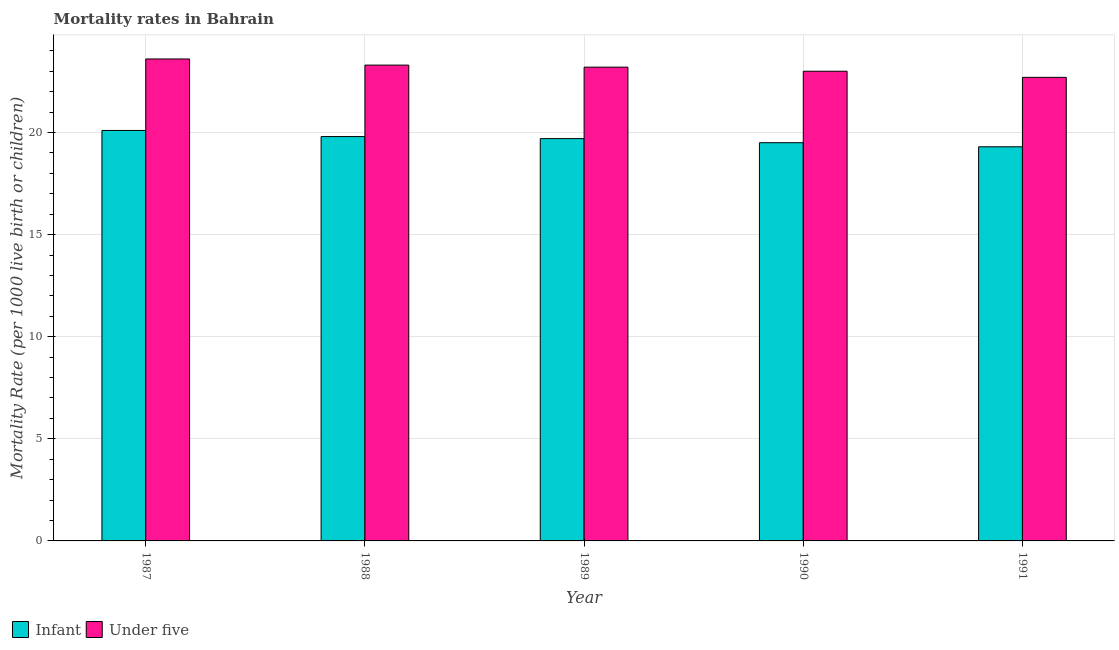Are the number of bars per tick equal to the number of legend labels?
Ensure brevity in your answer.  Yes. Are the number of bars on each tick of the X-axis equal?
Your response must be concise. Yes. How many bars are there on the 2nd tick from the right?
Ensure brevity in your answer.  2. Across all years, what is the maximum under-5 mortality rate?
Provide a short and direct response. 23.6. Across all years, what is the minimum infant mortality rate?
Your response must be concise. 19.3. In which year was the under-5 mortality rate maximum?
Provide a succinct answer. 1987. What is the total infant mortality rate in the graph?
Your answer should be very brief. 98.4. What is the difference between the infant mortality rate in 1987 and that in 1991?
Your answer should be compact. 0.8. What is the average infant mortality rate per year?
Offer a very short reply. 19.68. What is the ratio of the under-5 mortality rate in 1987 to that in 1989?
Offer a terse response. 1.02. Is the under-5 mortality rate in 1988 less than that in 1989?
Your answer should be compact. No. What is the difference between the highest and the second highest infant mortality rate?
Ensure brevity in your answer.  0.3. What is the difference between the highest and the lowest under-5 mortality rate?
Provide a short and direct response. 0.9. What does the 1st bar from the left in 1987 represents?
Offer a very short reply. Infant. What does the 1st bar from the right in 1987 represents?
Offer a very short reply. Under five. How many bars are there?
Offer a very short reply. 10. Are the values on the major ticks of Y-axis written in scientific E-notation?
Make the answer very short. No. Does the graph contain grids?
Your response must be concise. Yes. How are the legend labels stacked?
Provide a succinct answer. Horizontal. What is the title of the graph?
Ensure brevity in your answer.  Mortality rates in Bahrain. Does "Travel services" appear as one of the legend labels in the graph?
Ensure brevity in your answer.  No. What is the label or title of the Y-axis?
Make the answer very short. Mortality Rate (per 1000 live birth or children). What is the Mortality Rate (per 1000 live birth or children) of Infant in 1987?
Provide a succinct answer. 20.1. What is the Mortality Rate (per 1000 live birth or children) in Under five in 1987?
Keep it short and to the point. 23.6. What is the Mortality Rate (per 1000 live birth or children) of Infant in 1988?
Keep it short and to the point. 19.8. What is the Mortality Rate (per 1000 live birth or children) in Under five in 1988?
Provide a short and direct response. 23.3. What is the Mortality Rate (per 1000 live birth or children) in Under five in 1989?
Offer a terse response. 23.2. What is the Mortality Rate (per 1000 live birth or children) in Infant in 1991?
Make the answer very short. 19.3. What is the Mortality Rate (per 1000 live birth or children) in Under five in 1991?
Keep it short and to the point. 22.7. Across all years, what is the maximum Mortality Rate (per 1000 live birth or children) in Infant?
Offer a terse response. 20.1. Across all years, what is the maximum Mortality Rate (per 1000 live birth or children) of Under five?
Offer a very short reply. 23.6. Across all years, what is the minimum Mortality Rate (per 1000 live birth or children) in Infant?
Keep it short and to the point. 19.3. Across all years, what is the minimum Mortality Rate (per 1000 live birth or children) of Under five?
Your response must be concise. 22.7. What is the total Mortality Rate (per 1000 live birth or children) in Infant in the graph?
Keep it short and to the point. 98.4. What is the total Mortality Rate (per 1000 live birth or children) of Under five in the graph?
Make the answer very short. 115.8. What is the difference between the Mortality Rate (per 1000 live birth or children) of Infant in 1987 and that in 1988?
Make the answer very short. 0.3. What is the difference between the Mortality Rate (per 1000 live birth or children) in Infant in 1987 and that in 1989?
Keep it short and to the point. 0.4. What is the difference between the Mortality Rate (per 1000 live birth or children) of Under five in 1987 and that in 1989?
Your answer should be very brief. 0.4. What is the difference between the Mortality Rate (per 1000 live birth or children) of Infant in 1987 and that in 1990?
Keep it short and to the point. 0.6. What is the difference between the Mortality Rate (per 1000 live birth or children) of Under five in 1987 and that in 1990?
Provide a short and direct response. 0.6. What is the difference between the Mortality Rate (per 1000 live birth or children) in Under five in 1988 and that in 1989?
Your answer should be very brief. 0.1. What is the difference between the Mortality Rate (per 1000 live birth or children) in Infant in 1988 and that in 1990?
Provide a succinct answer. 0.3. What is the difference between the Mortality Rate (per 1000 live birth or children) of Under five in 1988 and that in 1991?
Give a very brief answer. 0.6. What is the difference between the Mortality Rate (per 1000 live birth or children) of Infant in 1989 and that in 1990?
Your response must be concise. 0.2. What is the difference between the Mortality Rate (per 1000 live birth or children) in Under five in 1989 and that in 1990?
Offer a terse response. 0.2. What is the difference between the Mortality Rate (per 1000 live birth or children) of Infant in 1989 and that in 1991?
Your response must be concise. 0.4. What is the difference between the Mortality Rate (per 1000 live birth or children) of Under five in 1989 and that in 1991?
Offer a terse response. 0.5. What is the difference between the Mortality Rate (per 1000 live birth or children) in Infant in 1990 and that in 1991?
Provide a succinct answer. 0.2. What is the difference between the Mortality Rate (per 1000 live birth or children) in Infant in 1987 and the Mortality Rate (per 1000 live birth or children) in Under five in 1988?
Give a very brief answer. -3.2. What is the difference between the Mortality Rate (per 1000 live birth or children) in Infant in 1987 and the Mortality Rate (per 1000 live birth or children) in Under five in 1989?
Offer a very short reply. -3.1. What is the difference between the Mortality Rate (per 1000 live birth or children) of Infant in 1989 and the Mortality Rate (per 1000 live birth or children) of Under five in 1990?
Your answer should be very brief. -3.3. What is the difference between the Mortality Rate (per 1000 live birth or children) in Infant in 1990 and the Mortality Rate (per 1000 live birth or children) in Under five in 1991?
Your answer should be very brief. -3.2. What is the average Mortality Rate (per 1000 live birth or children) in Infant per year?
Your response must be concise. 19.68. What is the average Mortality Rate (per 1000 live birth or children) in Under five per year?
Your response must be concise. 23.16. In the year 1987, what is the difference between the Mortality Rate (per 1000 live birth or children) of Infant and Mortality Rate (per 1000 live birth or children) of Under five?
Provide a short and direct response. -3.5. In the year 1991, what is the difference between the Mortality Rate (per 1000 live birth or children) of Infant and Mortality Rate (per 1000 live birth or children) of Under five?
Your answer should be compact. -3.4. What is the ratio of the Mortality Rate (per 1000 live birth or children) in Infant in 1987 to that in 1988?
Make the answer very short. 1.02. What is the ratio of the Mortality Rate (per 1000 live birth or children) in Under five in 1987 to that in 1988?
Offer a very short reply. 1.01. What is the ratio of the Mortality Rate (per 1000 live birth or children) of Infant in 1987 to that in 1989?
Give a very brief answer. 1.02. What is the ratio of the Mortality Rate (per 1000 live birth or children) in Under five in 1987 to that in 1989?
Offer a very short reply. 1.02. What is the ratio of the Mortality Rate (per 1000 live birth or children) of Infant in 1987 to that in 1990?
Keep it short and to the point. 1.03. What is the ratio of the Mortality Rate (per 1000 live birth or children) in Under five in 1987 to that in 1990?
Ensure brevity in your answer.  1.03. What is the ratio of the Mortality Rate (per 1000 live birth or children) in Infant in 1987 to that in 1991?
Your answer should be compact. 1.04. What is the ratio of the Mortality Rate (per 1000 live birth or children) of Under five in 1987 to that in 1991?
Provide a short and direct response. 1.04. What is the ratio of the Mortality Rate (per 1000 live birth or children) in Infant in 1988 to that in 1990?
Your answer should be very brief. 1.02. What is the ratio of the Mortality Rate (per 1000 live birth or children) of Infant in 1988 to that in 1991?
Offer a terse response. 1.03. What is the ratio of the Mortality Rate (per 1000 live birth or children) in Under five in 1988 to that in 1991?
Your response must be concise. 1.03. What is the ratio of the Mortality Rate (per 1000 live birth or children) of Infant in 1989 to that in 1990?
Your answer should be compact. 1.01. What is the ratio of the Mortality Rate (per 1000 live birth or children) of Under five in 1989 to that in 1990?
Offer a terse response. 1.01. What is the ratio of the Mortality Rate (per 1000 live birth or children) of Infant in 1989 to that in 1991?
Your response must be concise. 1.02. What is the ratio of the Mortality Rate (per 1000 live birth or children) in Under five in 1989 to that in 1991?
Make the answer very short. 1.02. What is the ratio of the Mortality Rate (per 1000 live birth or children) in Infant in 1990 to that in 1991?
Offer a terse response. 1.01. What is the ratio of the Mortality Rate (per 1000 live birth or children) in Under five in 1990 to that in 1991?
Offer a terse response. 1.01. What is the difference between the highest and the second highest Mortality Rate (per 1000 live birth or children) of Infant?
Give a very brief answer. 0.3. What is the difference between the highest and the second highest Mortality Rate (per 1000 live birth or children) in Under five?
Make the answer very short. 0.3. 